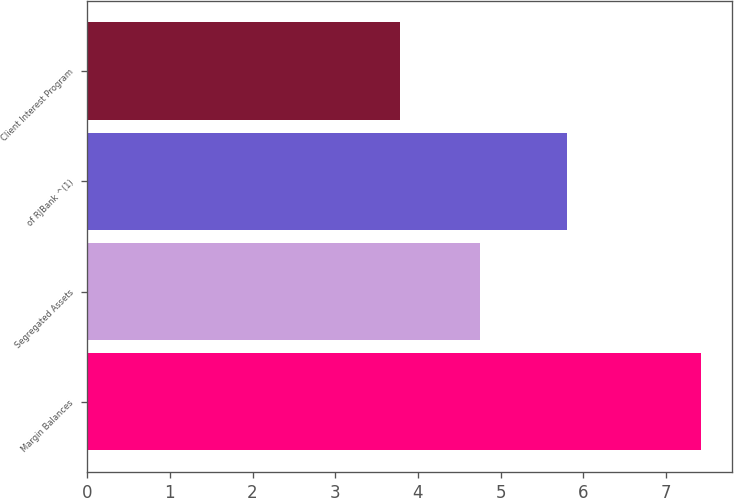Convert chart to OTSL. <chart><loc_0><loc_0><loc_500><loc_500><bar_chart><fcel>Margin Balances<fcel>Segregated Assets<fcel>of RJBank ^(1)<fcel>Client Interest Program<nl><fcel>7.42<fcel>4.75<fcel>5.8<fcel>3.78<nl></chart> 